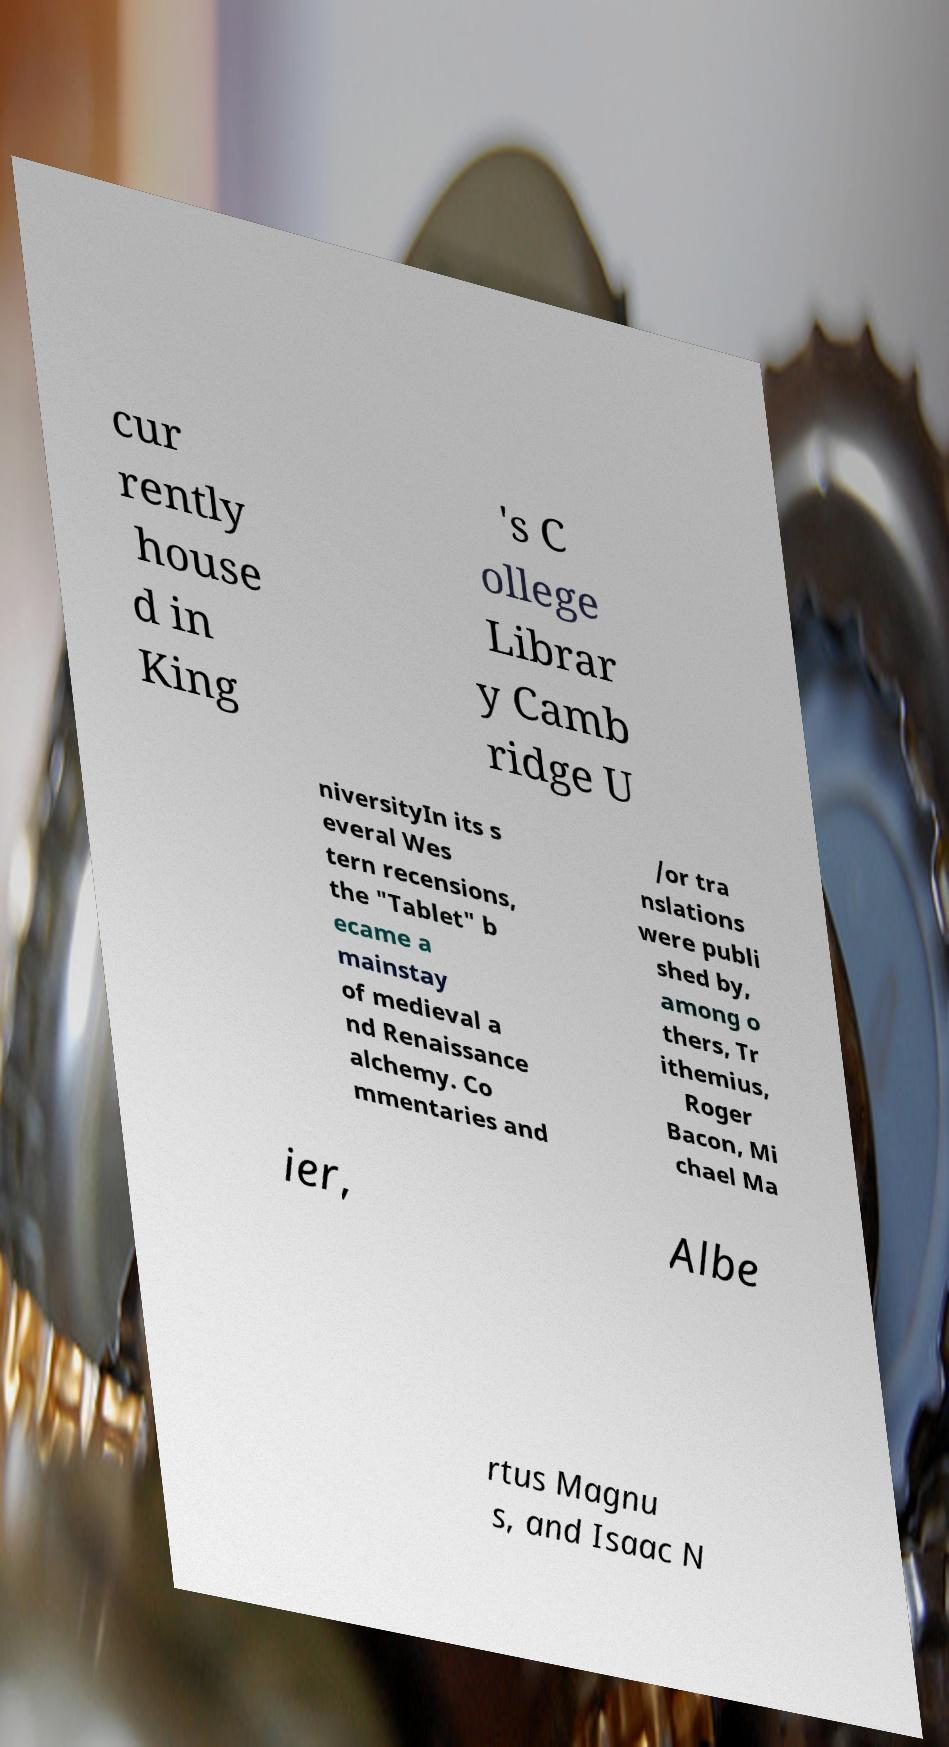For documentation purposes, I need the text within this image transcribed. Could you provide that? cur rently house d in King 's C ollege Librar y Camb ridge U niversityIn its s everal Wes tern recensions, the "Tablet" b ecame a mainstay of medieval a nd Renaissance alchemy. Co mmentaries and /or tra nslations were publi shed by, among o thers, Tr ithemius, Roger Bacon, Mi chael Ma ier, Albe rtus Magnu s, and Isaac N 